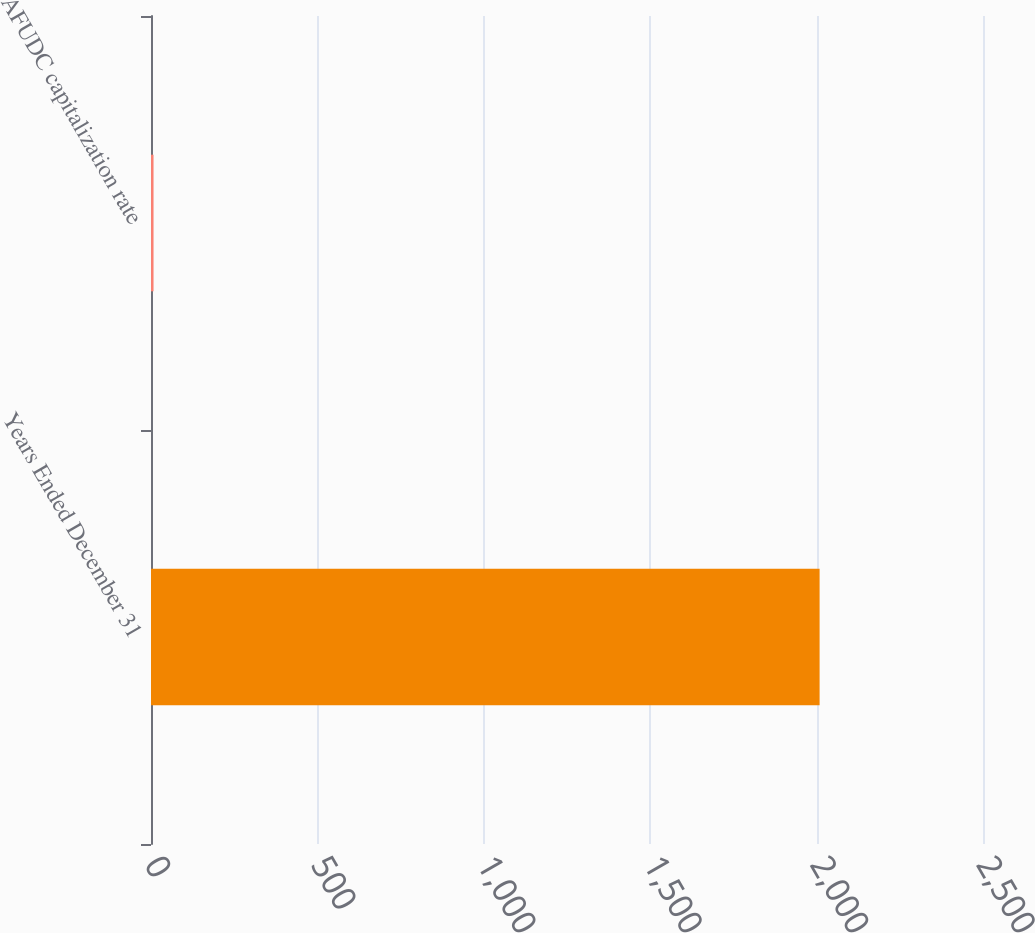Convert chart to OTSL. <chart><loc_0><loc_0><loc_500><loc_500><bar_chart><fcel>Years Ended December 31<fcel>AFUDC capitalization rate<nl><fcel>2009<fcel>7.6<nl></chart> 